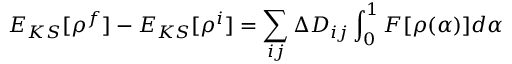Convert formula to latex. <formula><loc_0><loc_0><loc_500><loc_500>E _ { K S } [ \rho ^ { f } ] - E _ { K S } [ \rho ^ { i } ] = \sum _ { i j } \Delta D _ { i j } \int _ { 0 } ^ { 1 } F [ \rho ( \alpha ) ] d \alpha</formula> 